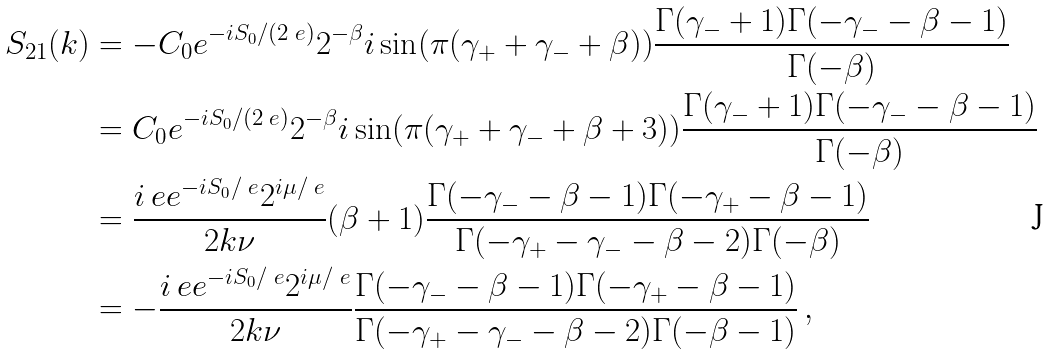<formula> <loc_0><loc_0><loc_500><loc_500>S _ { 2 1 } ( k ) & = - C _ { 0 } e ^ { - i S _ { 0 } / ( 2 \ e ) } 2 ^ { - \beta } i \sin ( \pi ( \gamma _ { + } + \gamma _ { - } + \beta ) ) \frac { \Gamma ( \gamma _ { - } + 1 ) \Gamma ( - \gamma _ { - } - \beta - 1 ) } { \Gamma ( - \beta ) } \\ & = C _ { 0 } e ^ { - i S _ { 0 } / ( 2 \ e ) } 2 ^ { - \beta } i \sin ( \pi ( \gamma _ { + } + \gamma _ { - } + \beta + 3 ) ) \frac { \Gamma ( \gamma _ { - } + 1 ) \Gamma ( - \gamma _ { - } - \beta - 1 ) } { \Gamma ( - \beta ) } \\ & = \frac { i \ e e ^ { - i S _ { 0 } / \ e } 2 ^ { i \mu / \ e } } { 2 k \nu } ( \beta + 1 ) \frac { \Gamma ( - \gamma _ { - } - \beta - 1 ) \Gamma ( - \gamma _ { + } - \beta - 1 ) } { \Gamma ( - \gamma _ { + } - \gamma _ { - } - \beta - 2 ) \Gamma ( - \beta ) } \\ & = - \frac { i \ e e ^ { - i S _ { 0 } / \ e } 2 ^ { i \mu / \ e } } { 2 k \nu } \frac { \Gamma ( - \gamma _ { - } - \beta - 1 ) \Gamma ( - \gamma _ { + } - \beta - 1 ) } { \Gamma ( - \gamma _ { + } - \gamma _ { - } - \beta - 2 ) \Gamma ( - \beta - 1 ) } \, ,</formula> 